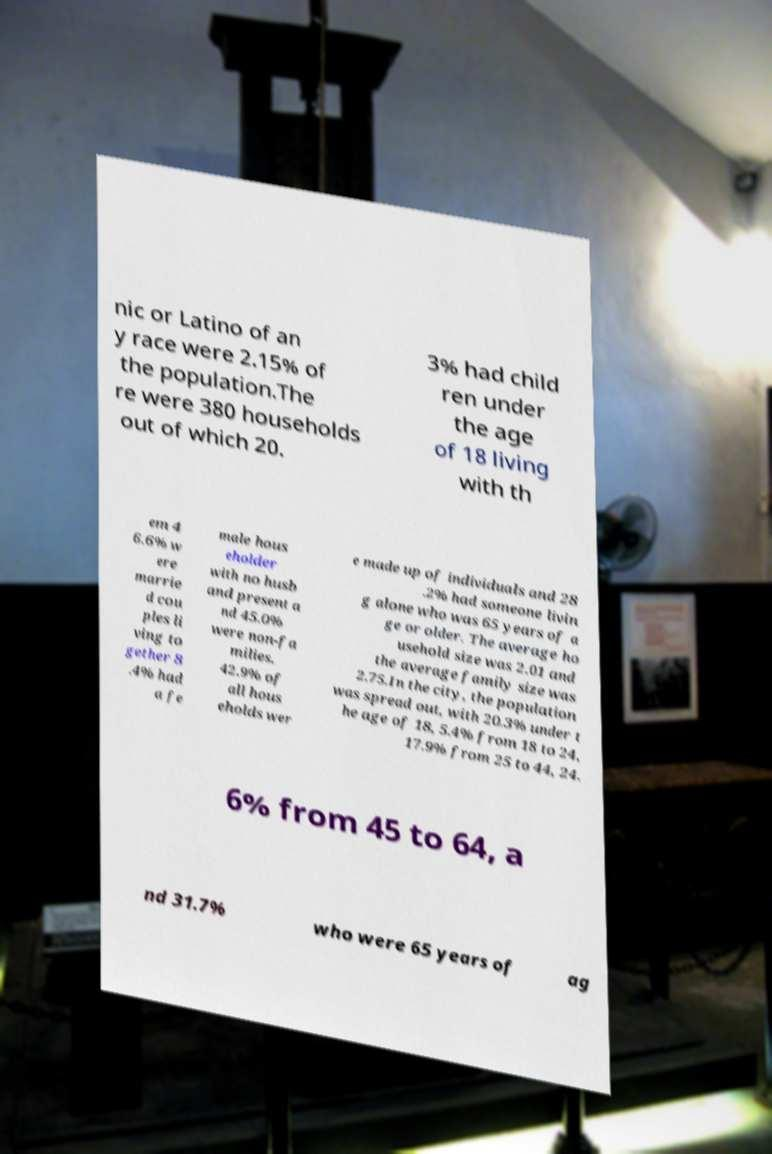Please read and relay the text visible in this image. What does it say? nic or Latino of an y race were 2.15% of the population.The re were 380 households out of which 20. 3% had child ren under the age of 18 living with th em 4 6.6% w ere marrie d cou ples li ving to gether 8 .4% had a fe male hous eholder with no husb and present a nd 45.0% were non-fa milies. 42.9% of all hous eholds wer e made up of individuals and 28 .2% had someone livin g alone who was 65 years of a ge or older. The average ho usehold size was 2.01 and the average family size was 2.75.In the city, the population was spread out, with 20.3% under t he age of 18, 5.4% from 18 to 24, 17.9% from 25 to 44, 24. 6% from 45 to 64, a nd 31.7% who were 65 years of ag 